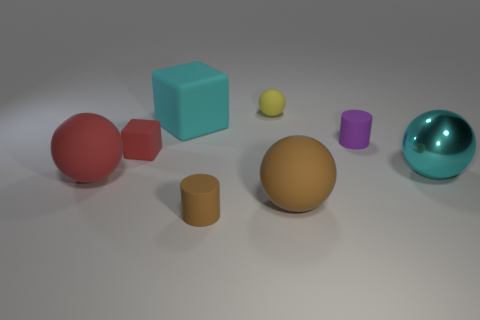There is a shiny thing that is the same shape as the yellow rubber object; what color is it?
Provide a short and direct response. Cyan. Are there any other things that are the same color as the big matte block?
Keep it short and to the point. Yes. What is the shape of the big cyan object that is to the right of the small matte thing in front of the cyan object right of the tiny yellow thing?
Your response must be concise. Sphere. Does the object left of the red matte cube have the same size as the brown thing right of the small brown thing?
Keep it short and to the point. Yes. How many large cyan cubes are the same material as the tiny purple object?
Offer a terse response. 1. There is a large cyan object in front of the small matte cylinder that is behind the brown rubber cylinder; how many rubber balls are behind it?
Provide a succinct answer. 1. Is the shape of the small brown matte object the same as the big red thing?
Keep it short and to the point. No. Are there any yellow things that have the same shape as the big red rubber thing?
Offer a very short reply. Yes. There is a purple rubber object that is the same size as the yellow rubber sphere; what is its shape?
Provide a succinct answer. Cylinder. There is a red object left of the tiny rubber thing that is on the left side of the cyan object behind the cyan ball; what is it made of?
Offer a very short reply. Rubber. 